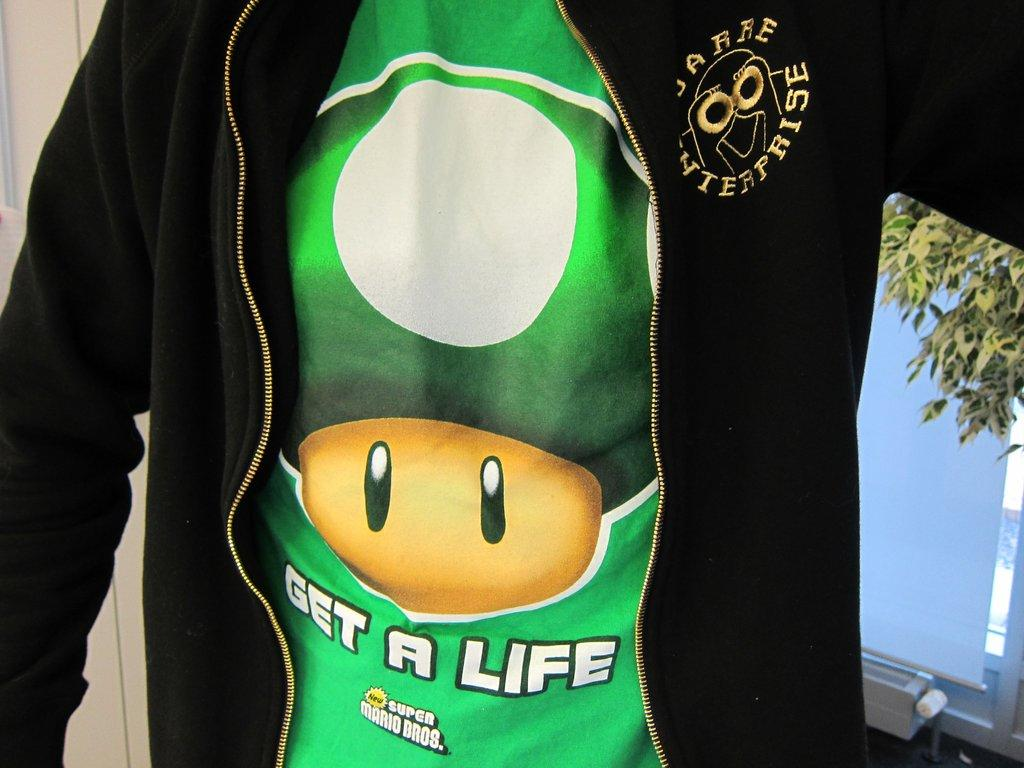What type of clothing is featured in the image? There is a t-shirt and a black jacket in the image. Can you describe the background of the image? There are leaves visible in the background of the image, along with some other objects. What type of trip can be seen in the image? There is no trip visible in the image; it features a t-shirt, a black jacket, and a background with leaves and other objects. 